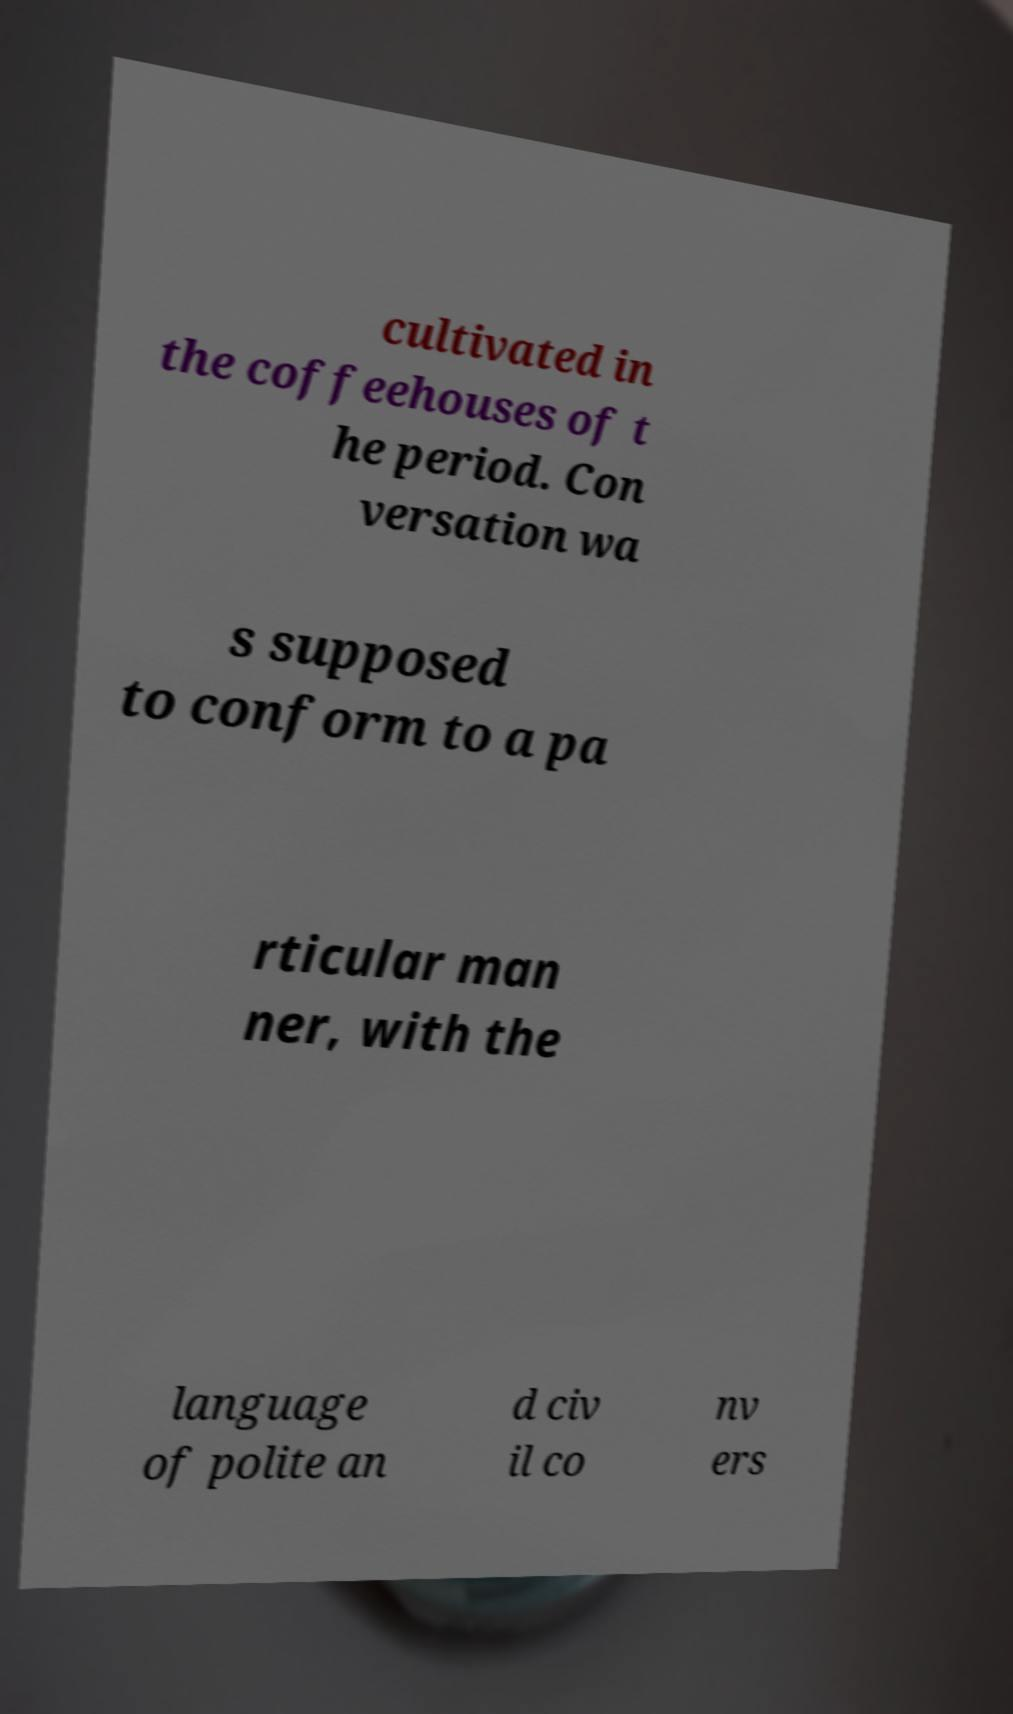Please read and relay the text visible in this image. What does it say? cultivated in the coffeehouses of t he period. Con versation wa s supposed to conform to a pa rticular man ner, with the language of polite an d civ il co nv ers 